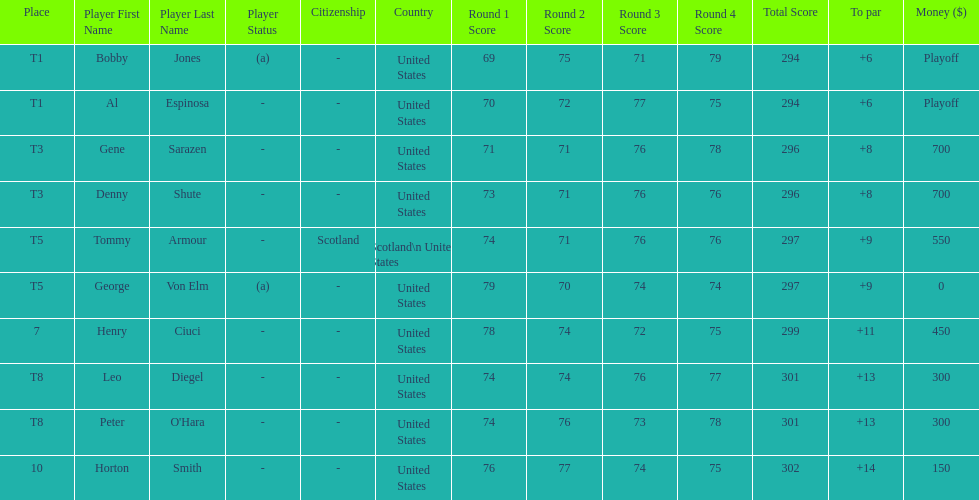Who was the last player in the top 10? Horton Smith. 